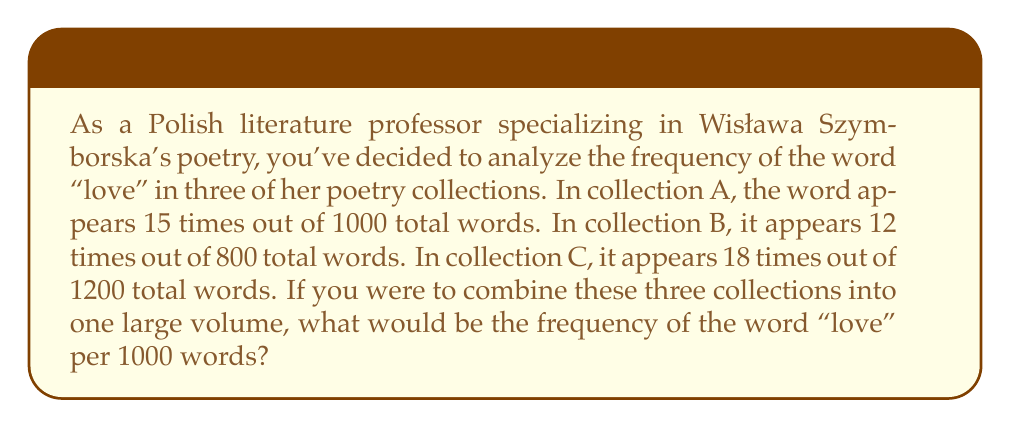Show me your answer to this math problem. To solve this problem, we need to follow these steps:

1. Calculate the total number of times "love" appears across all collections:
   $15 + 12 + 18 = 45$ times

2. Calculate the total number of words across all collections:
   $1000 + 800 + 1200 = 3000$ words

3. Set up the frequency ratio:
   $\frac{45 \text{ occurrences of "love"}}{3000 \text{ total words}}$

4. To find the frequency per 1000 words, we can set up a proportion:
   $$\frac{45}{3000} = \frac{x}{1000}$$

5. Cross multiply:
   $$45 \cdot 1000 = 3000x$$

6. Solve for x:
   $$x = \frac{45 \cdot 1000}{3000} = 15$$

Therefore, in the combined volume, the word "love" would appear 15 times per 1000 words.
Answer: 15 times per 1000 words 